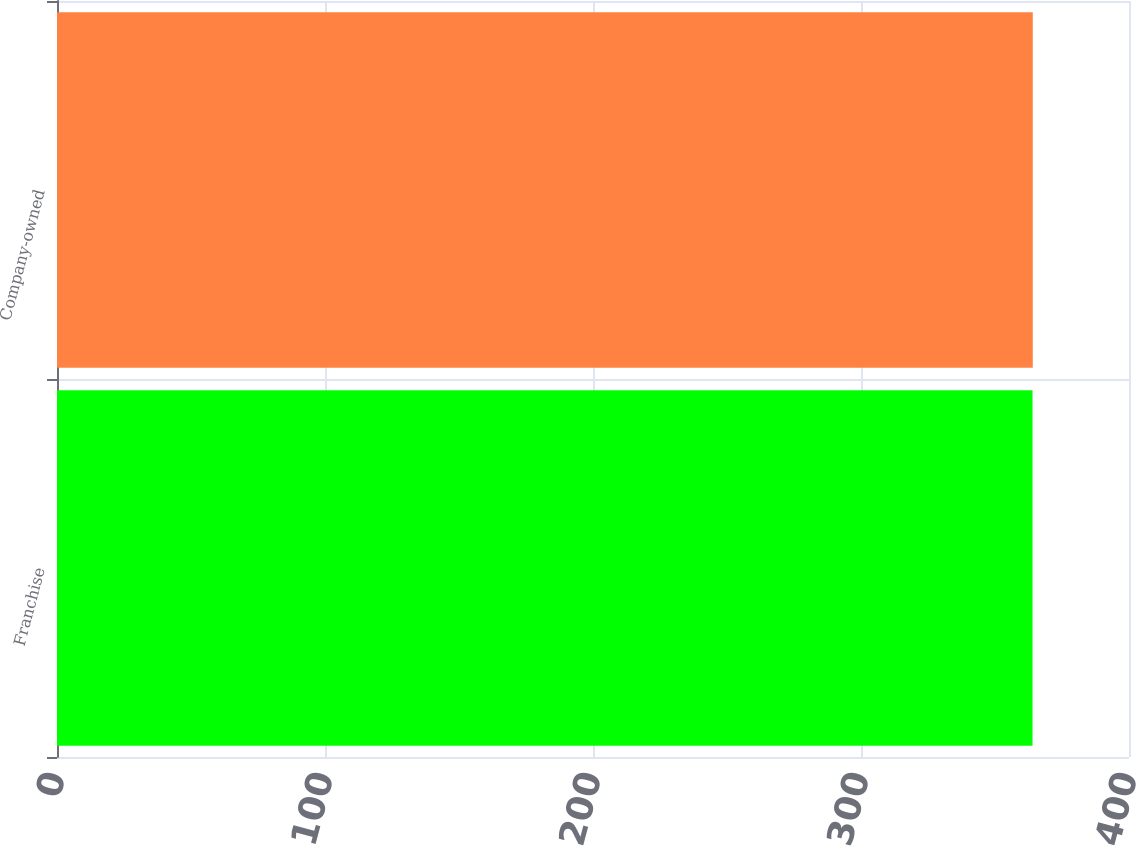Convert chart to OTSL. <chart><loc_0><loc_0><loc_500><loc_500><bar_chart><fcel>Franchise<fcel>Company-owned<nl><fcel>364<fcel>364.1<nl></chart> 